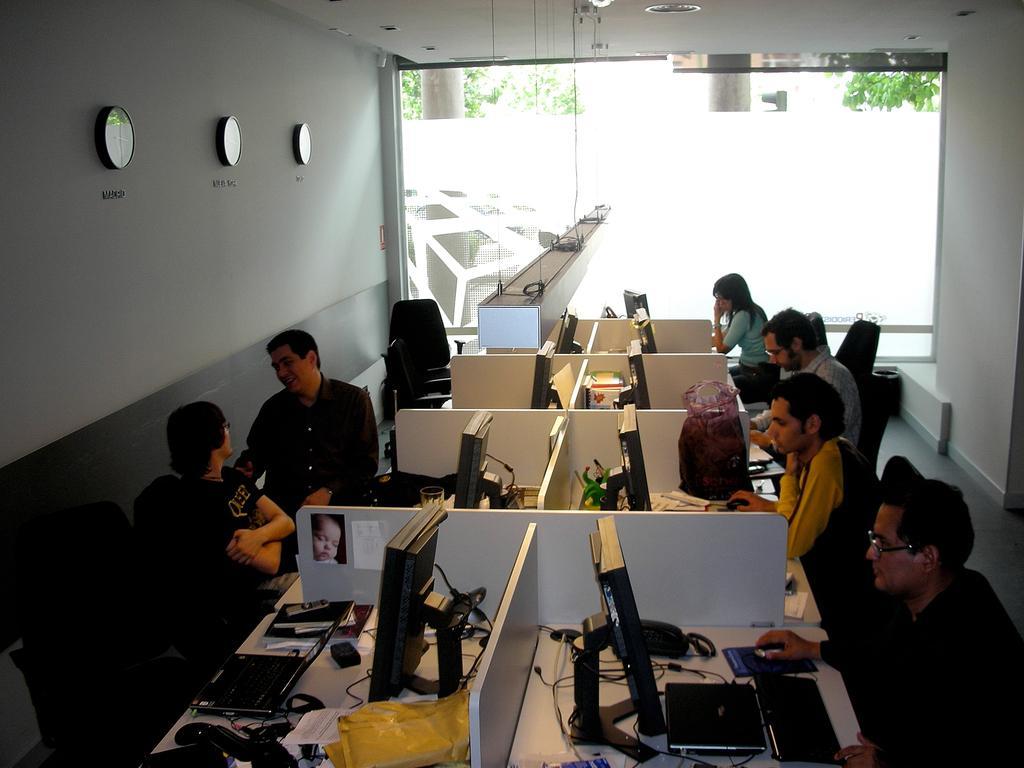Could you give a brief overview of what you see in this image? In this image we can see the inner view of a room and there are a few people sitting on chairs and we can see the cubicles with computers and some other objects. We can see the wall with objects which looks like the clocks and in the background, we can see the glass window and also there are some trees. 